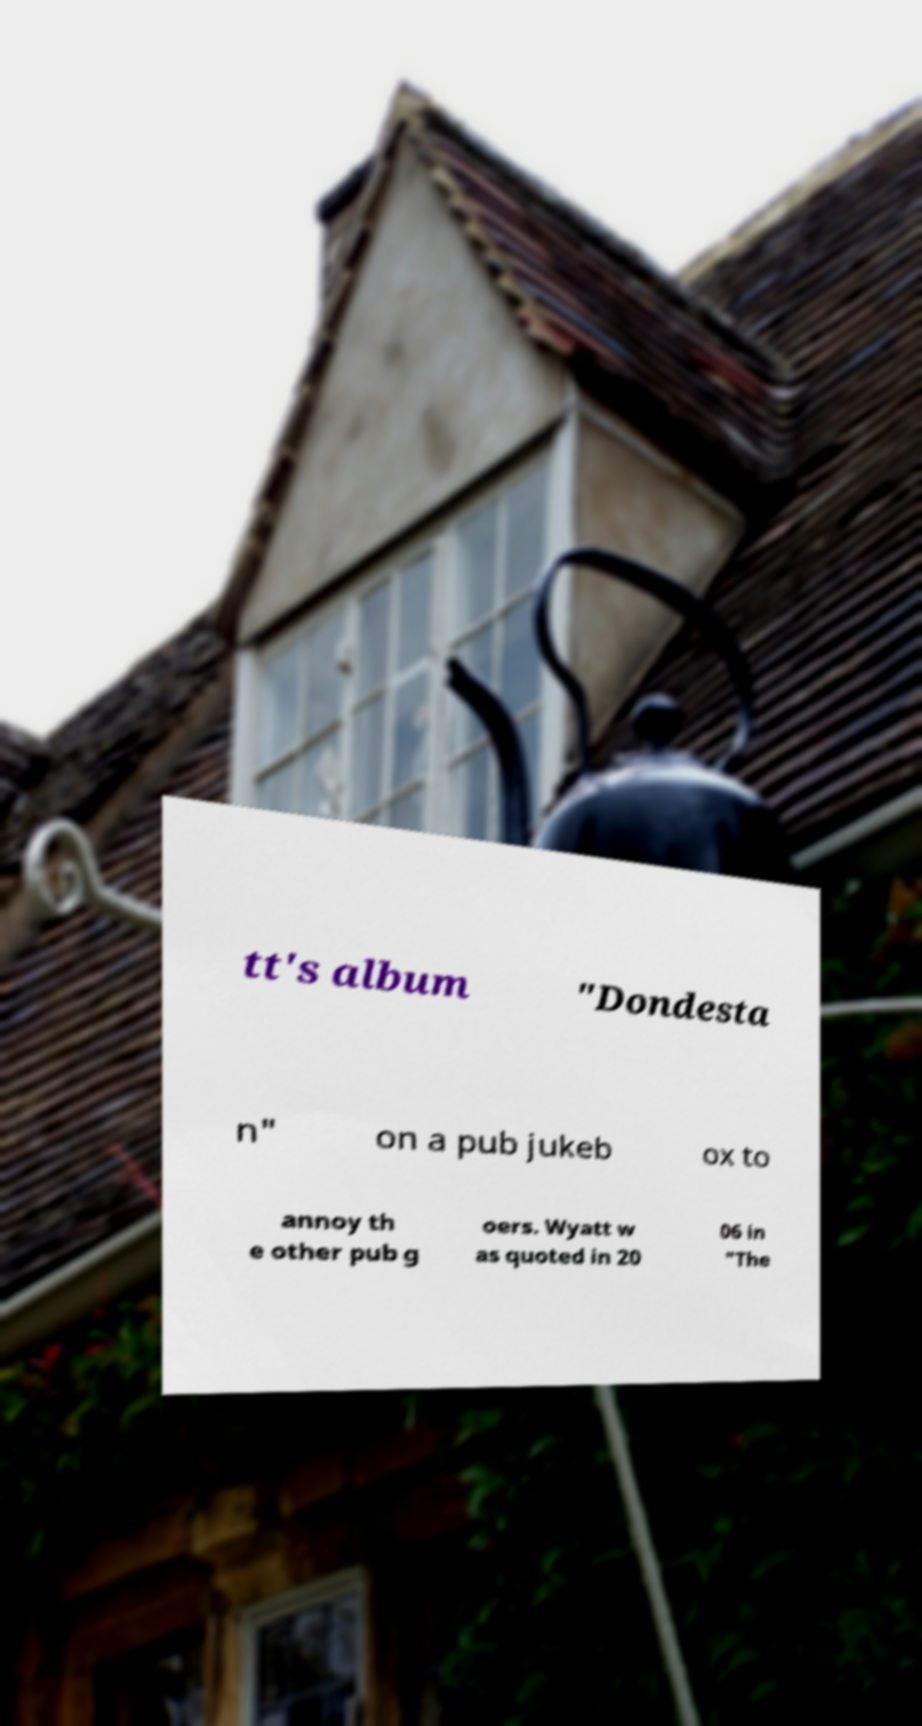Please identify and transcribe the text found in this image. tt's album "Dondesta n" on a pub jukeb ox to annoy th e other pub g oers. Wyatt w as quoted in 20 06 in "The 